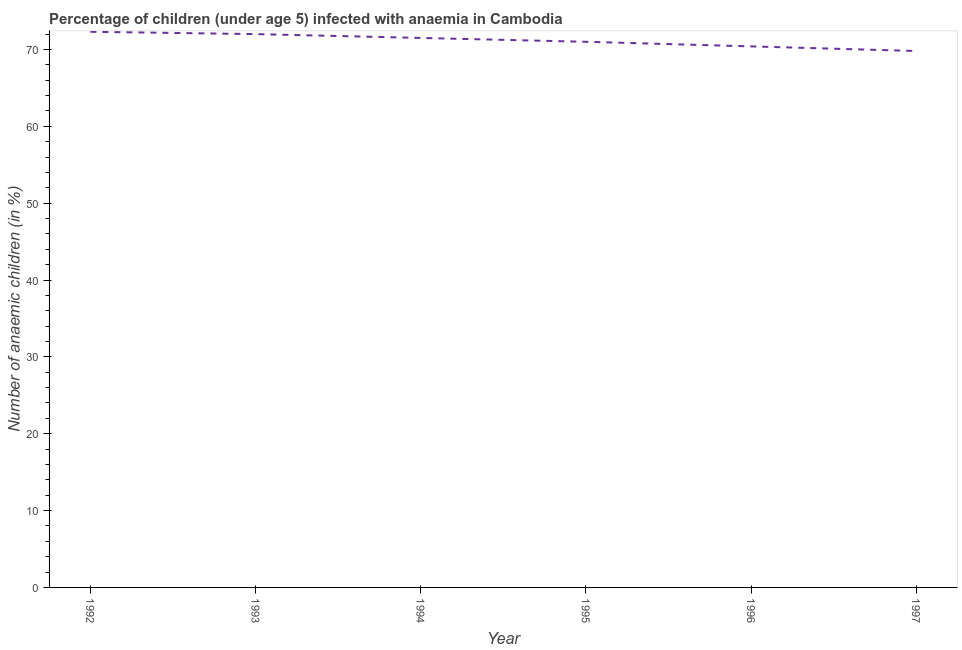What is the number of anaemic children in 1992?
Provide a succinct answer. 72.3. Across all years, what is the maximum number of anaemic children?
Ensure brevity in your answer.  72.3. Across all years, what is the minimum number of anaemic children?
Make the answer very short. 69.8. In which year was the number of anaemic children maximum?
Your answer should be very brief. 1992. In which year was the number of anaemic children minimum?
Offer a very short reply. 1997. What is the sum of the number of anaemic children?
Your response must be concise. 427. What is the average number of anaemic children per year?
Your response must be concise. 71.17. What is the median number of anaemic children?
Offer a terse response. 71.25. Do a majority of the years between 1993 and 1992 (inclusive) have number of anaemic children greater than 20 %?
Your answer should be compact. No. What is the ratio of the number of anaemic children in 1993 to that in 1994?
Provide a succinct answer. 1.01. Is the difference between the number of anaemic children in 1995 and 1996 greater than the difference between any two years?
Provide a short and direct response. No. What is the difference between the highest and the second highest number of anaemic children?
Give a very brief answer. 0.3. What is the difference between the highest and the lowest number of anaemic children?
Provide a succinct answer. 2.5. In how many years, is the number of anaemic children greater than the average number of anaemic children taken over all years?
Provide a succinct answer. 3. Does the number of anaemic children monotonically increase over the years?
Your answer should be compact. No. What is the difference between two consecutive major ticks on the Y-axis?
Ensure brevity in your answer.  10. Are the values on the major ticks of Y-axis written in scientific E-notation?
Make the answer very short. No. Does the graph contain grids?
Your response must be concise. No. What is the title of the graph?
Offer a terse response. Percentage of children (under age 5) infected with anaemia in Cambodia. What is the label or title of the X-axis?
Provide a short and direct response. Year. What is the label or title of the Y-axis?
Offer a terse response. Number of anaemic children (in %). What is the Number of anaemic children (in %) in 1992?
Make the answer very short. 72.3. What is the Number of anaemic children (in %) of 1994?
Offer a very short reply. 71.5. What is the Number of anaemic children (in %) of 1996?
Offer a terse response. 70.4. What is the Number of anaemic children (in %) of 1997?
Ensure brevity in your answer.  69.8. What is the difference between the Number of anaemic children (in %) in 1992 and 1994?
Provide a short and direct response. 0.8. What is the difference between the Number of anaemic children (in %) in 1992 and 1995?
Keep it short and to the point. 1.3. What is the difference between the Number of anaemic children (in %) in 1992 and 1997?
Make the answer very short. 2.5. What is the difference between the Number of anaemic children (in %) in 1993 and 1995?
Keep it short and to the point. 1. What is the difference between the Number of anaemic children (in %) in 1993 and 1996?
Your response must be concise. 1.6. What is the difference between the Number of anaemic children (in %) in 1993 and 1997?
Offer a very short reply. 2.2. What is the difference between the Number of anaemic children (in %) in 1994 and 1995?
Give a very brief answer. 0.5. What is the difference between the Number of anaemic children (in %) in 1994 and 1996?
Give a very brief answer. 1.1. What is the difference between the Number of anaemic children (in %) in 1994 and 1997?
Your answer should be very brief. 1.7. What is the difference between the Number of anaemic children (in %) in 1996 and 1997?
Offer a terse response. 0.6. What is the ratio of the Number of anaemic children (in %) in 1992 to that in 1993?
Ensure brevity in your answer.  1. What is the ratio of the Number of anaemic children (in %) in 1992 to that in 1995?
Offer a terse response. 1.02. What is the ratio of the Number of anaemic children (in %) in 1992 to that in 1996?
Provide a succinct answer. 1.03. What is the ratio of the Number of anaemic children (in %) in 1992 to that in 1997?
Ensure brevity in your answer.  1.04. What is the ratio of the Number of anaemic children (in %) in 1993 to that in 1994?
Ensure brevity in your answer.  1.01. What is the ratio of the Number of anaemic children (in %) in 1993 to that in 1997?
Make the answer very short. 1.03. What is the ratio of the Number of anaemic children (in %) in 1994 to that in 1995?
Provide a short and direct response. 1.01. What is the ratio of the Number of anaemic children (in %) in 1995 to that in 1997?
Ensure brevity in your answer.  1.02. 